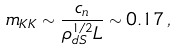<formula> <loc_0><loc_0><loc_500><loc_500>m _ { K K } \sim \frac { c _ { n } } { \rho _ { d S } ^ { 1 / 2 } L } \sim 0 . 1 7 \, ,</formula> 